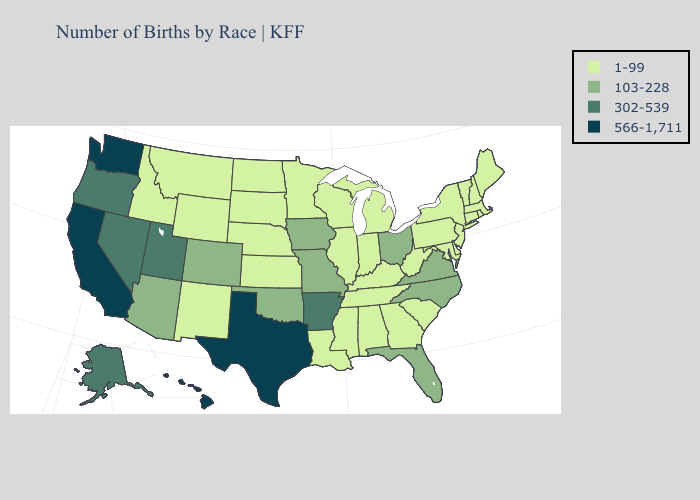Which states have the lowest value in the West?
Be succinct. Idaho, Montana, New Mexico, Wyoming. Name the states that have a value in the range 302-539?
Short answer required. Alaska, Arkansas, Nevada, Oregon, Utah. What is the highest value in the USA?
Give a very brief answer. 566-1,711. Among the states that border Indiana , does Illinois have the lowest value?
Write a very short answer. Yes. Name the states that have a value in the range 1-99?
Be succinct. Alabama, Connecticut, Delaware, Georgia, Idaho, Illinois, Indiana, Kansas, Kentucky, Louisiana, Maine, Maryland, Massachusetts, Michigan, Minnesota, Mississippi, Montana, Nebraska, New Hampshire, New Jersey, New Mexico, New York, North Dakota, Pennsylvania, Rhode Island, South Carolina, South Dakota, Tennessee, Vermont, West Virginia, Wisconsin, Wyoming. What is the value of Tennessee?
Concise answer only. 1-99. What is the value of Tennessee?
Give a very brief answer. 1-99. Does Ohio have the highest value in the MidWest?
Give a very brief answer. Yes. What is the value of Montana?
Answer briefly. 1-99. Does Montana have the lowest value in the West?
Write a very short answer. Yes. Among the states that border Indiana , which have the highest value?
Short answer required. Ohio. What is the highest value in the South ?
Give a very brief answer. 566-1,711. Among the states that border Wyoming , which have the lowest value?
Write a very short answer. Idaho, Montana, Nebraska, South Dakota. Name the states that have a value in the range 103-228?
Short answer required. Arizona, Colorado, Florida, Iowa, Missouri, North Carolina, Ohio, Oklahoma, Virginia. 